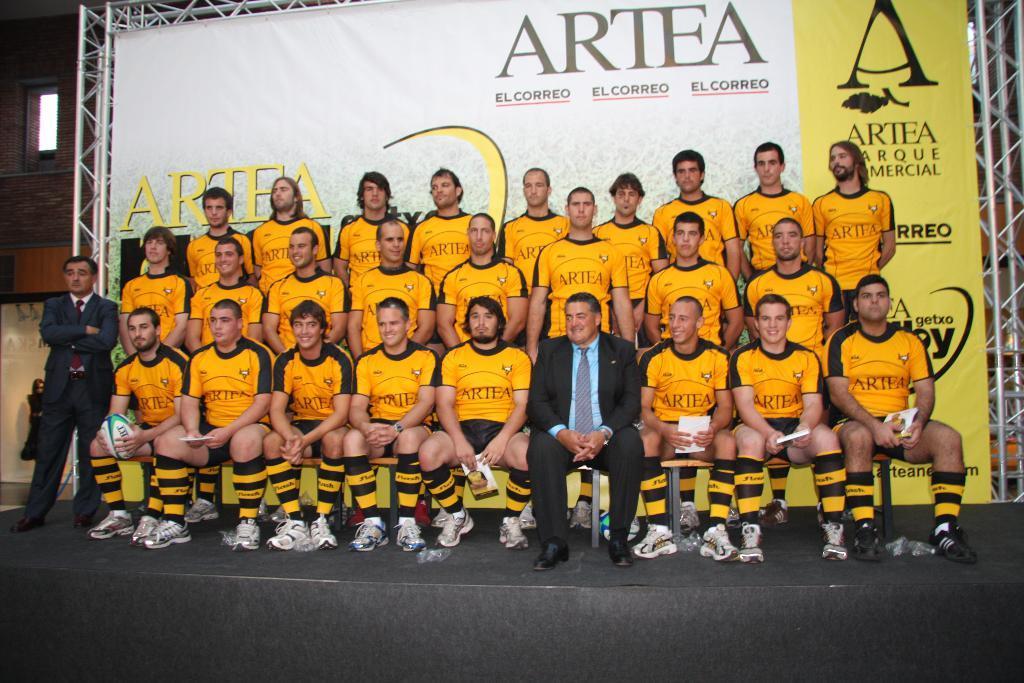Please provide a concise description of this image. In this image there are few people sitting on a bench and few are standing, in the background there is a banner and there is some text and there is a metal frame. 